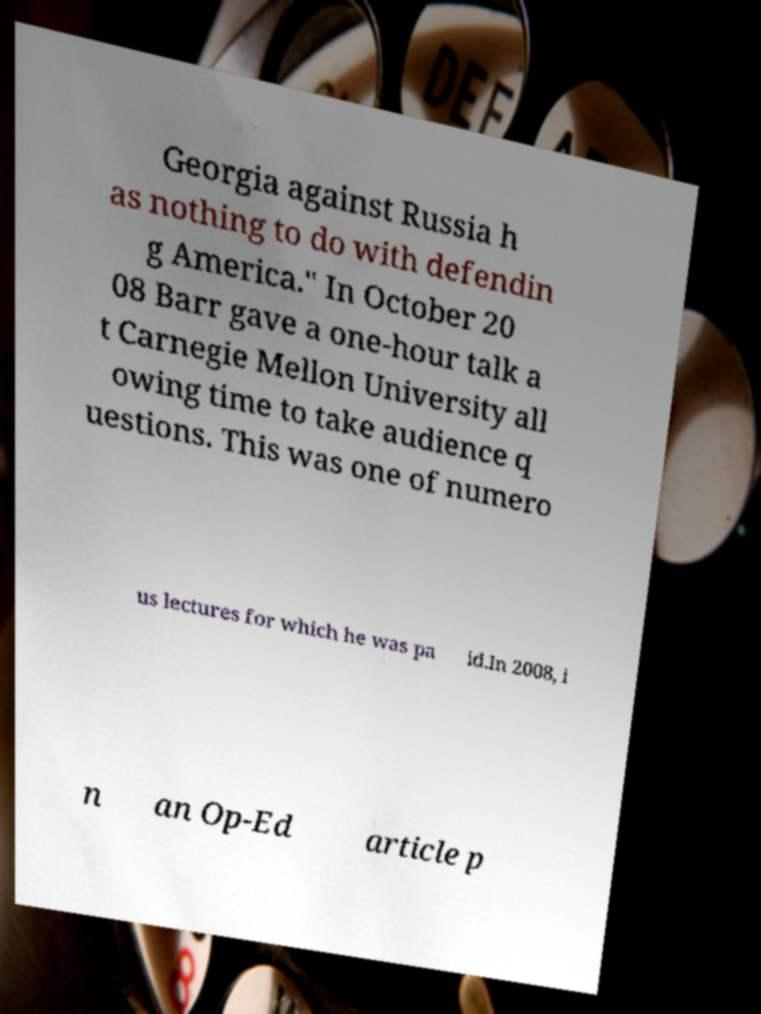What messages or text are displayed in this image? I need them in a readable, typed format. Georgia against Russia h as nothing to do with defendin g America." In October 20 08 Barr gave a one-hour talk a t Carnegie Mellon University all owing time to take audience q uestions. This was one of numero us lectures for which he was pa id.In 2008, i n an Op-Ed article p 